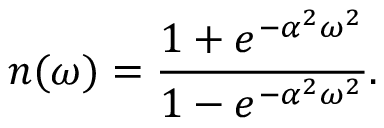<formula> <loc_0><loc_0><loc_500><loc_500>n ( \omega ) = { \frac { 1 + e ^ { - \alpha ^ { 2 } \omega ^ { 2 } } } { 1 - e ^ { - \alpha ^ { 2 } \omega ^ { 2 } } } } .</formula> 